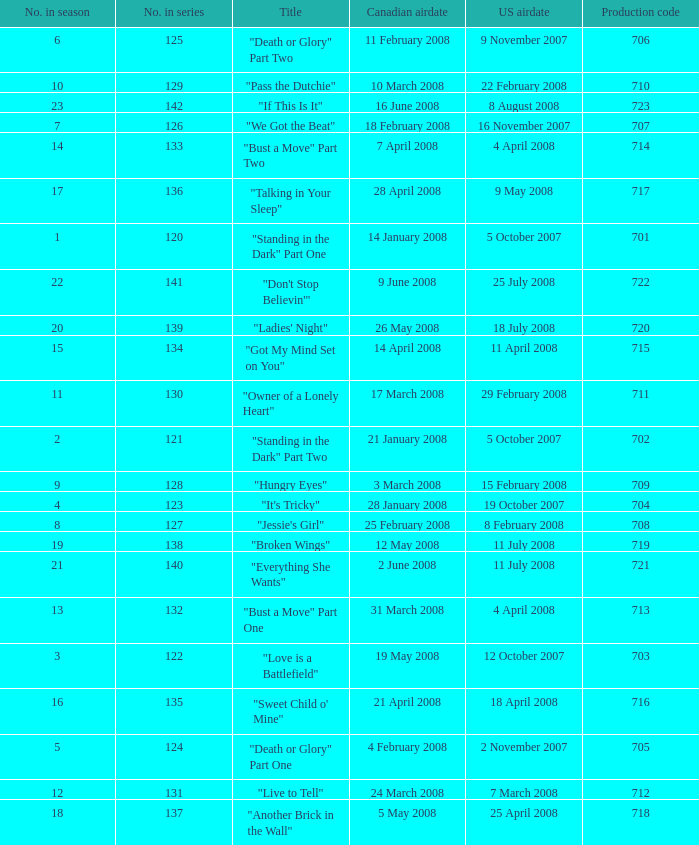The canadian airdate of 11 february 2008 applied to what series number? 1.0. 